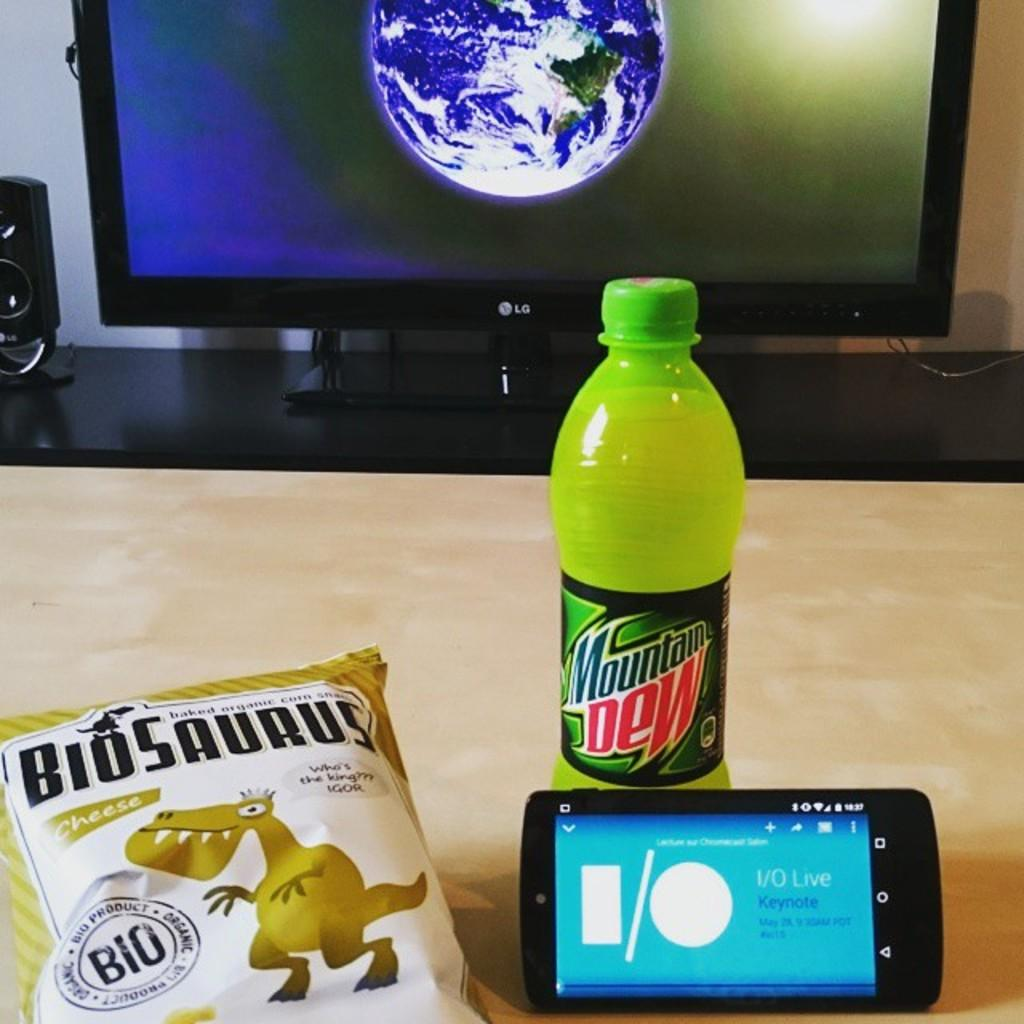<image>
Share a concise interpretation of the image provided. A bottle of mountain dew is on a table next to a phone and a bag of BioSaurus snacks. 